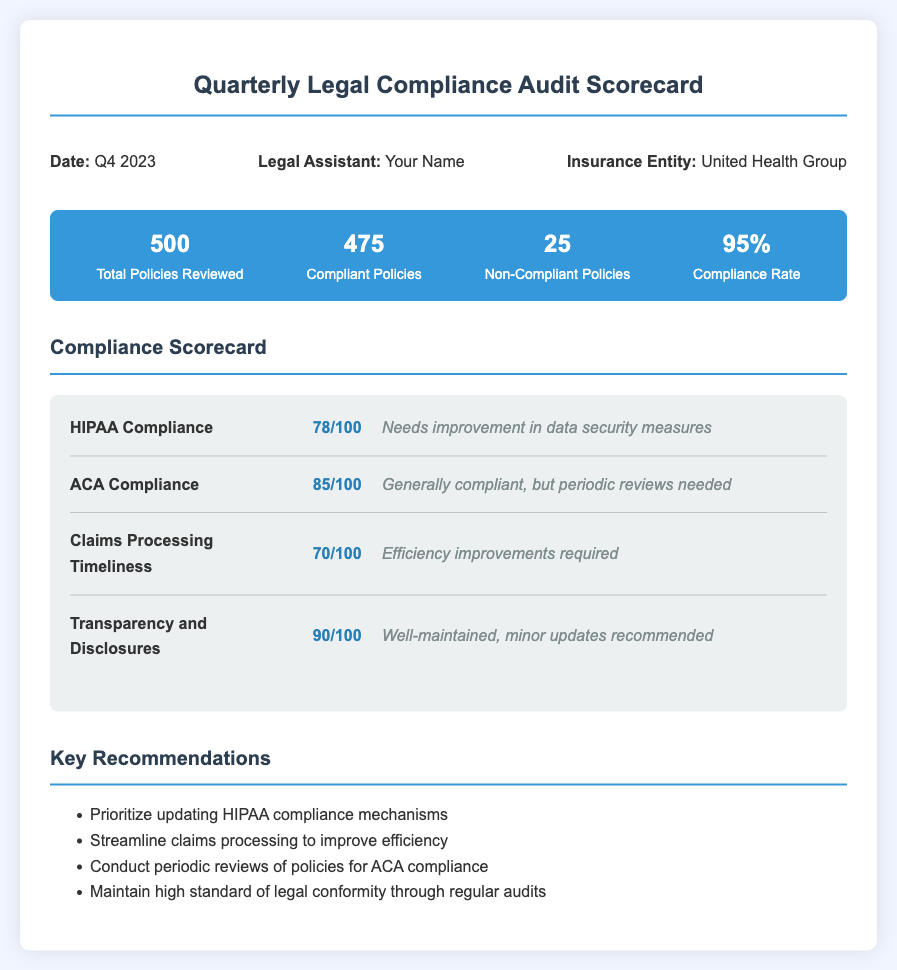What is the date of the report? The report is dated Q4 2023, as indicated in the document.
Answer: Q4 2023 Who is the legal assistant listed in the document? The document lists "Your Name" as the legal assistant working on the report.
Answer: Your Name How many total policies were reviewed? The total number of policies reviewed is mentioned in the metrics section, which is 500.
Answer: 500 What is the compliance rate? The compliance rate is provided in the metrics section, which shows 95%.
Answer: 95% What score did the HIPAA Compliance receive? The score for HIPAA Compliance is stated in the scorecard as 78 out of 100.
Answer: 78/100 Which compliance area requires efficiency improvements? The compliance area that requires efficiency improvements is identified as Claims Processing Timeliness, which scored 70/100.
Answer: Claims Processing Timeliness What percentage of policies were compliant? The compliant policies are shown as 475 out of a total of 500 policies reviewed, which leads to 95%.
Answer: 95% What is one key recommendation made in the document? The key recommendations section lists several suggestions, one being to prioritize updating HIPAA compliance mechanisms.
Answer: Prioritize updating HIPAA compliance mechanisms Which criterion had the highest score? Transparency and Disclosures received the highest score as indicated in the scorecard, which is 90 out of 100.
Answer: Transparency and Disclosures 